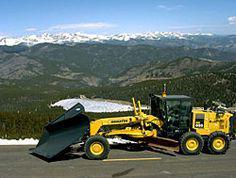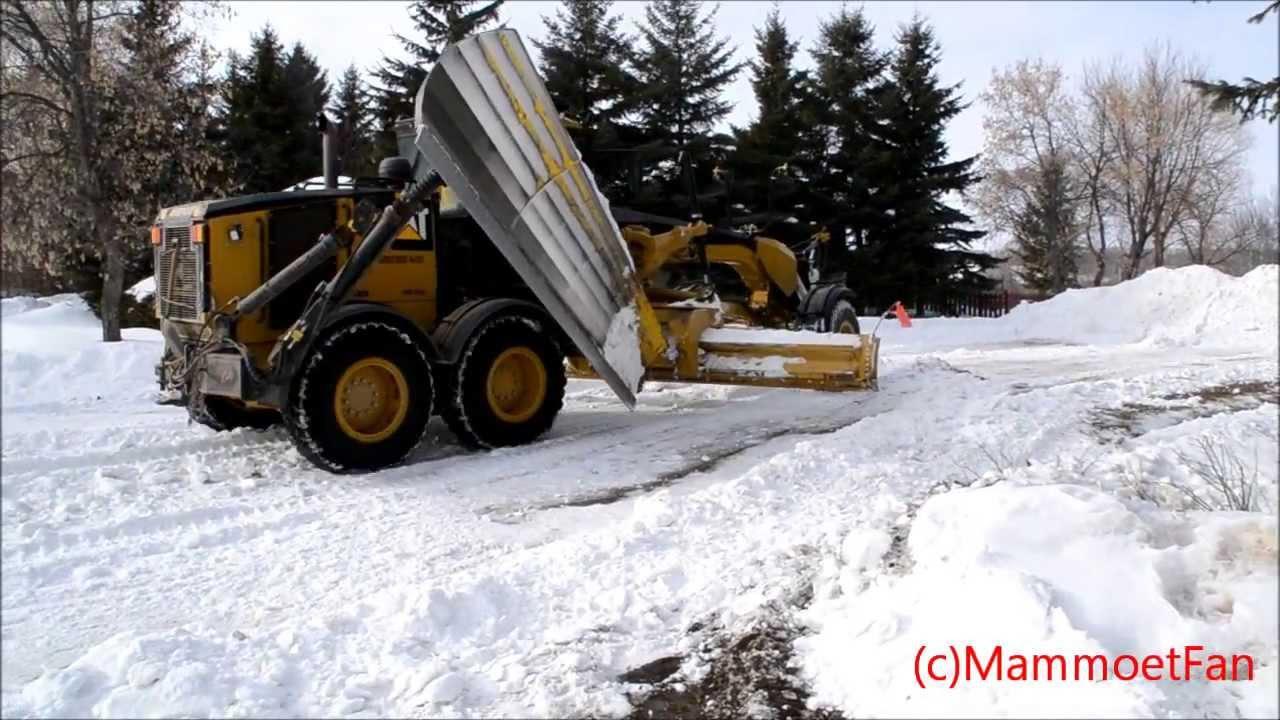The first image is the image on the left, the second image is the image on the right. Assess this claim about the two images: "The left and right image contains the same number of yellow snow plows.". Correct or not? Answer yes or no. Yes. 